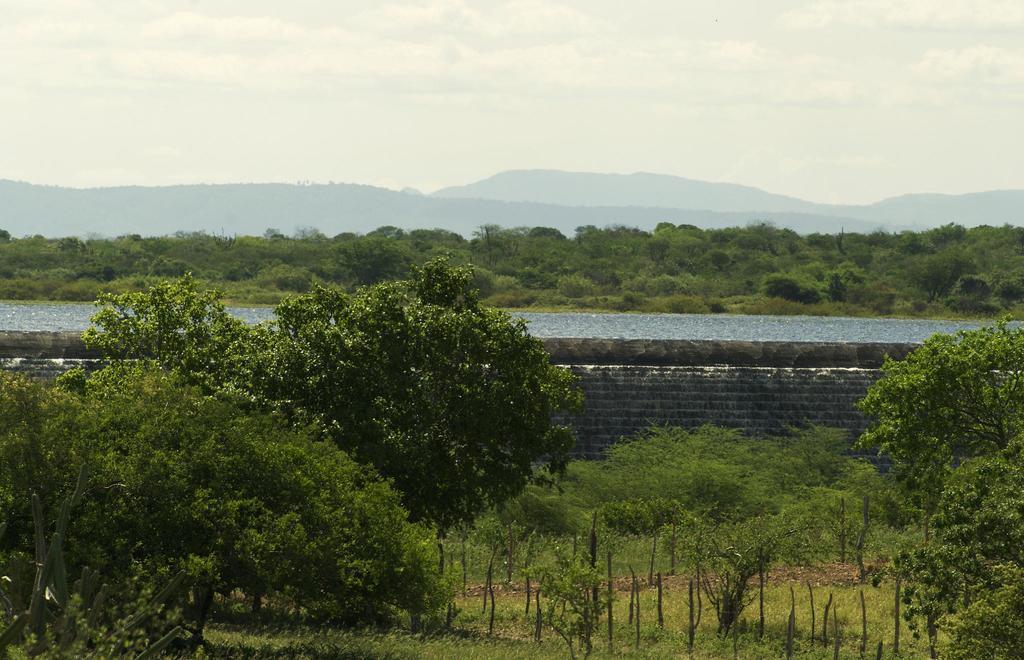In one or two sentences, can you explain what this image depicts? These are trees of green color, this is water and a sky. 